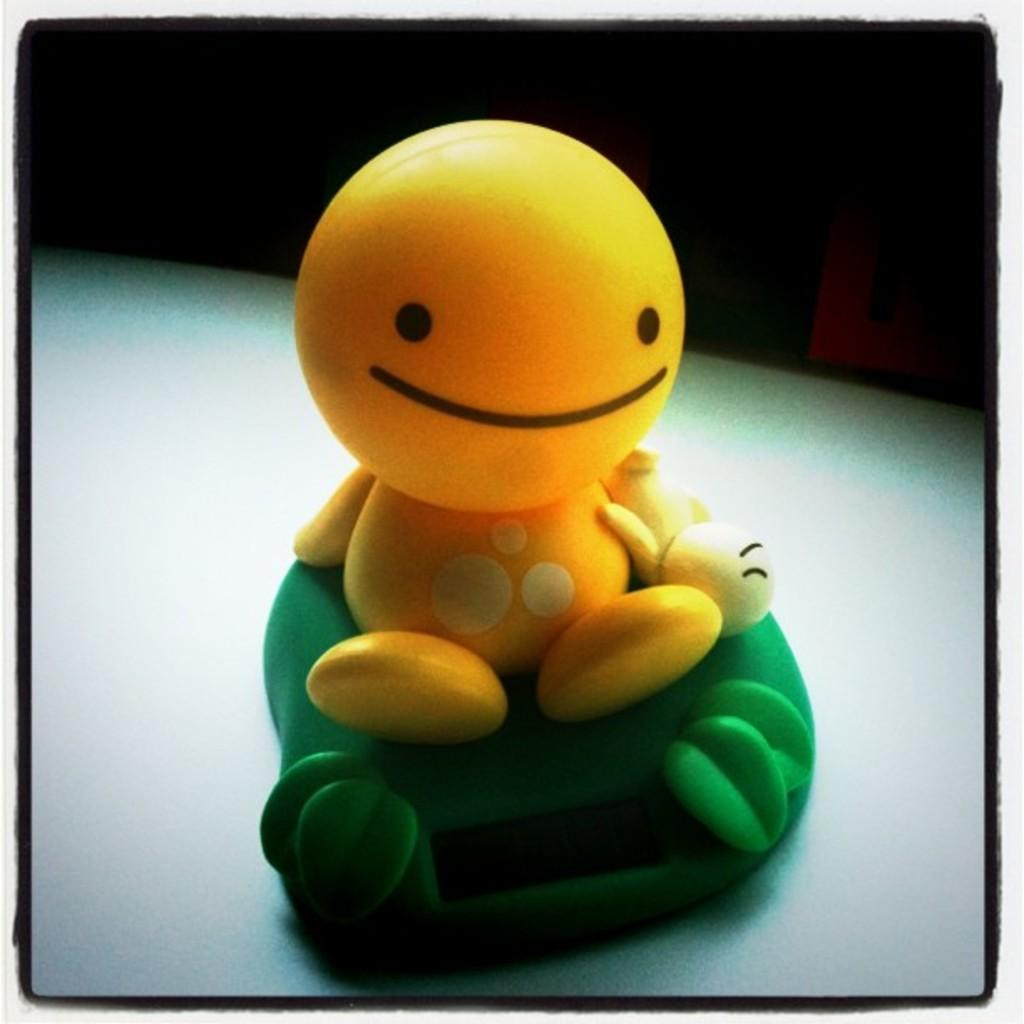What is the color of the toy that is visible in the image? The toy in the image is yellow. What is the color of the other object in the image? The other object in the image is green. What religion is being practiced in the image? There is no indication of any religious practice in the image. How many attempts were made to boil water in the kettle in the image? There is no kettle present in the image. 